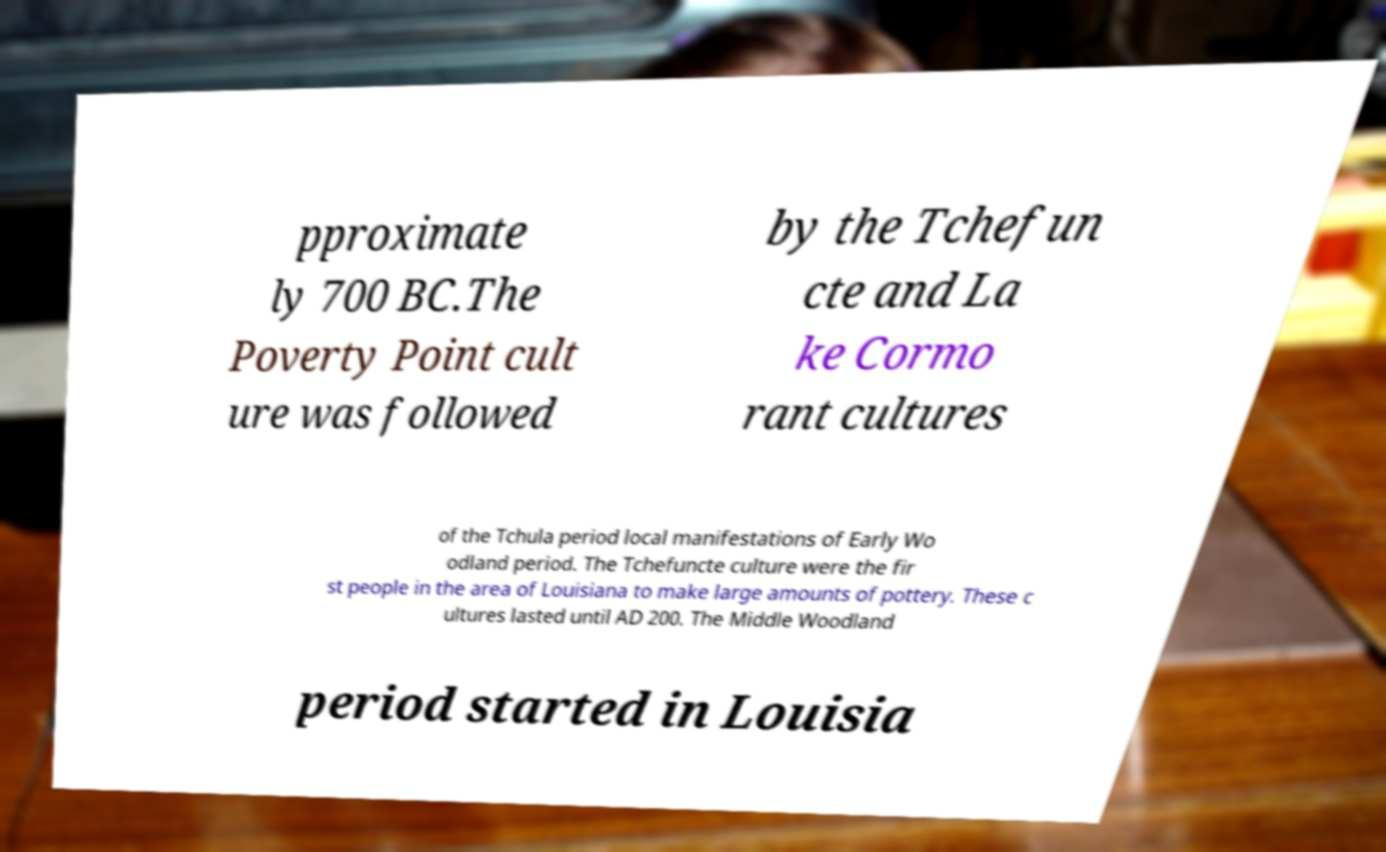Could you extract and type out the text from this image? pproximate ly 700 BC.The Poverty Point cult ure was followed by the Tchefun cte and La ke Cormo rant cultures of the Tchula period local manifestations of Early Wo odland period. The Tchefuncte culture were the fir st people in the area of Louisiana to make large amounts of pottery. These c ultures lasted until AD 200. The Middle Woodland period started in Louisia 